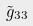<formula> <loc_0><loc_0><loc_500><loc_500>\tilde { g } _ { 3 3 }</formula> 